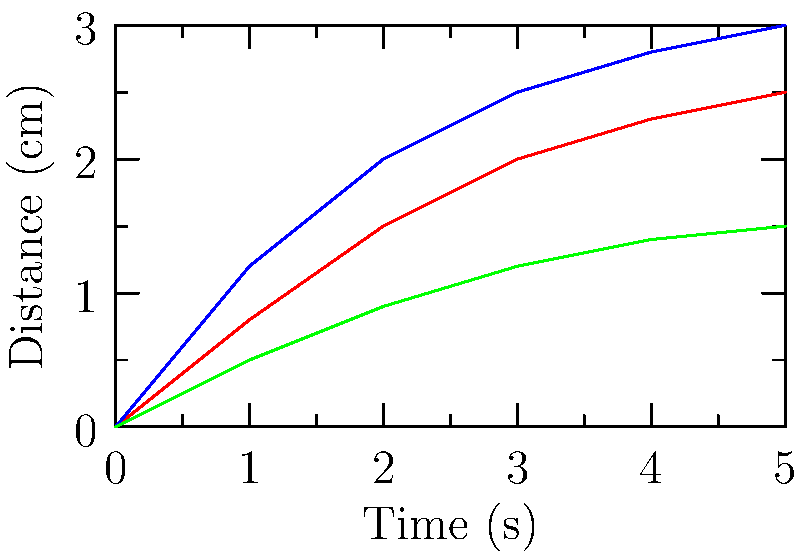Based on the flow diagrams of three different emulsions (A, B, and C) shown above, which emulsion exhibits the highest viscosity? To determine the viscosity of the emulsions from the flow diagrams, we need to analyze the relationship between time and distance traveled:

1. The x-axis represents time (in seconds), and the y-axis represents distance traveled (in cm).
2. A steeper slope indicates faster flow, which corresponds to lower viscosity.
3. A gentler slope indicates slower flow, which corresponds to higher viscosity.

Analyzing each emulsion:

1. Emulsion A (red line): Shows a moderate slope, indicating medium viscosity.
2. Emulsion B (blue line): Has the steepest slope, indicating the fastest flow and lowest viscosity.
3. Emulsion C (green line): Has the gentlest slope, indicating the slowest flow and highest viscosity.

Therefore, Emulsion C exhibits the highest viscosity as it travels the shortest distance over the given time period.
Answer: Emulsion C 